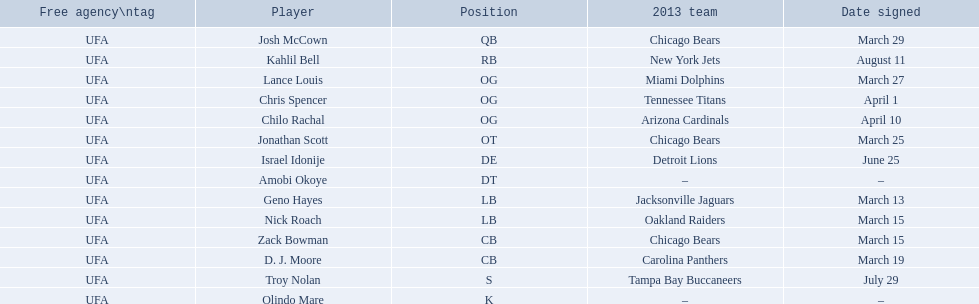Who are all the players on the 2013 chicago bears season team? Josh McCown, Kahlil Bell, Lance Louis, Chris Spencer, Chilo Rachal, Jonathan Scott, Israel Idonije, Amobi Okoye, Geno Hayes, Nick Roach, Zack Bowman, D. J. Moore, Troy Nolan, Olindo Mare. What day was nick roach signed? March 15. What other day matches this? March 15. Who was signed on the day? Zack Bowman. 